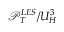<formula> <loc_0><loc_0><loc_500><loc_500>\mathcal { P } _ { T } ^ { L E S } / U _ { H } ^ { 3 }</formula> 